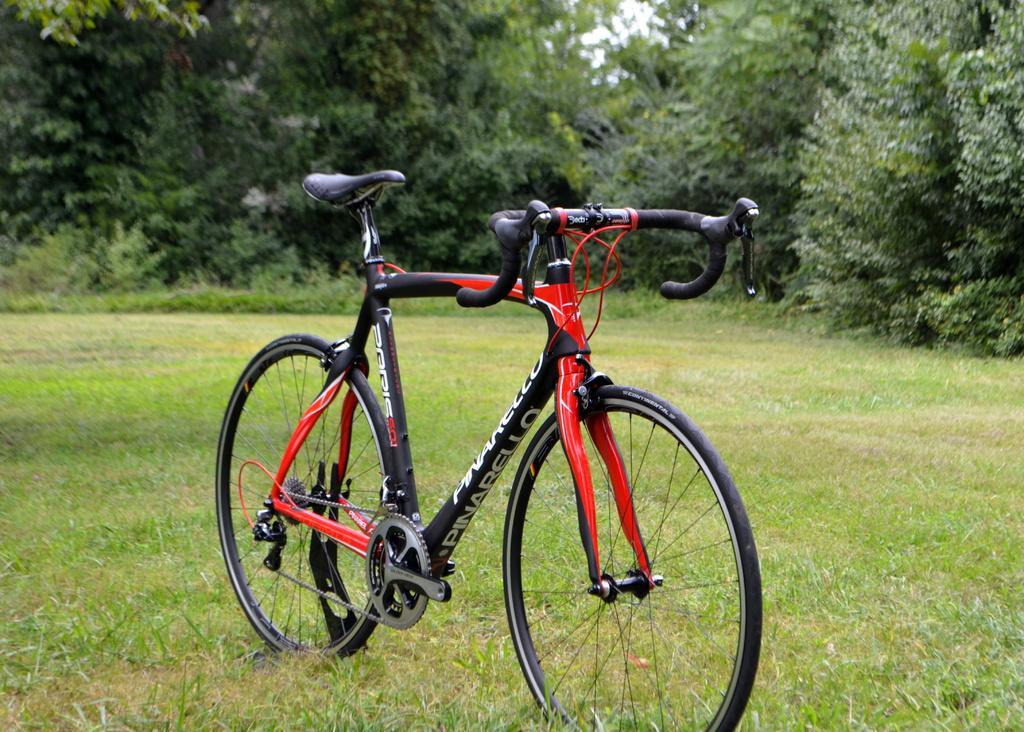In one or two sentences, can you explain what this image depicts? In this picture there is a bicycle in the center of the image and there is grassland in the image and there are trees at the top side of the image. 